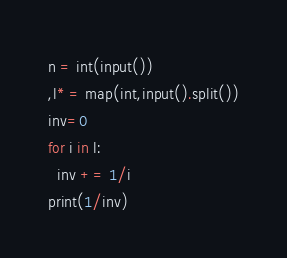Convert code to text. <code><loc_0><loc_0><loc_500><loc_500><_Python_>n = int(input())
,l* = map(int,input().split())
inv=0
for i in l:
  inv += 1/i
print(1/inv)</code> 